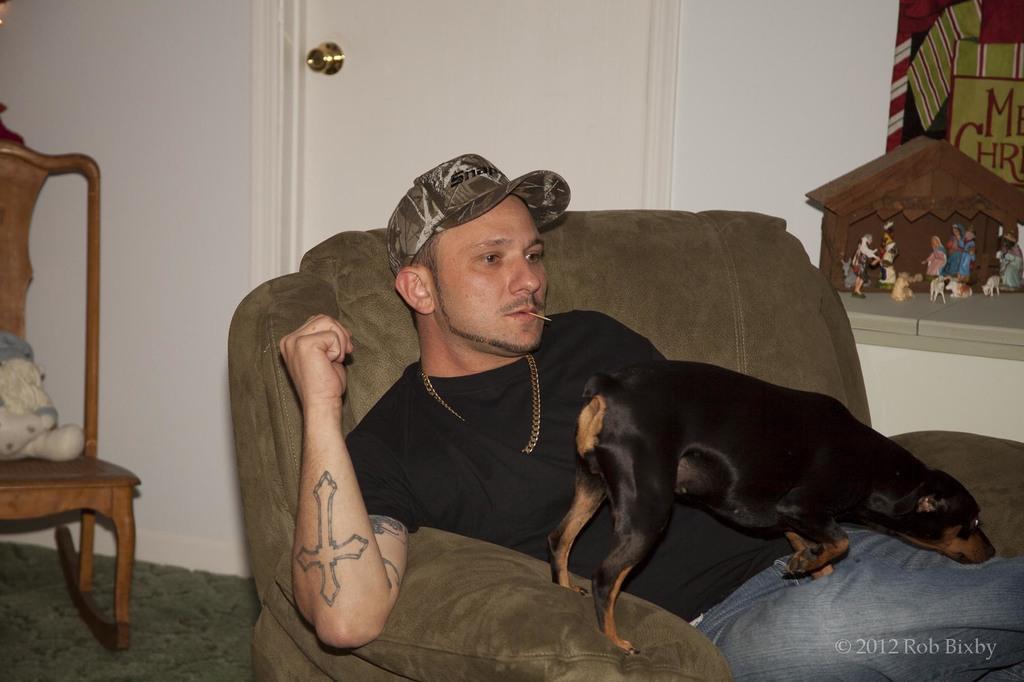Could you give a brief overview of what you see in this image? In this image a man wearing a cap on his head is sitting on the sofa and on top of him there is a dog which is black color. In the left side of the image there is a chair and there is a teddy bear on it. At the bottom of the image there is a floor with mat. In the background there is a wall and a door and there are few toys on the wall. 